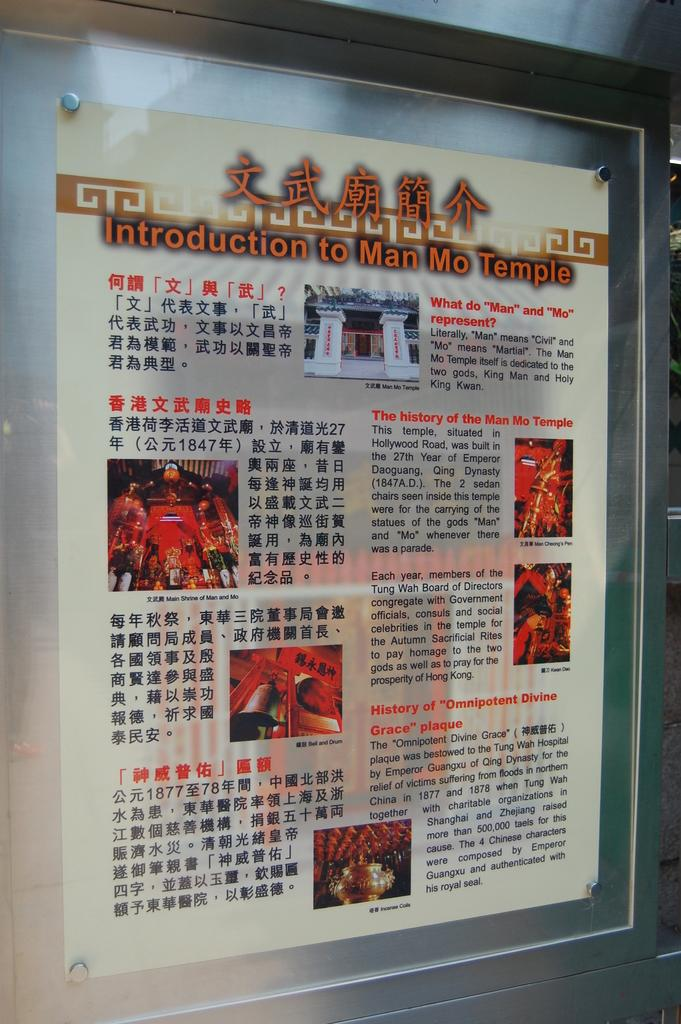Provide a one-sentence caption for the provided image. Paper framed on a wall that says Introduction to Man Mo Temple. 